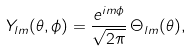Convert formula to latex. <formula><loc_0><loc_0><loc_500><loc_500>Y _ { l m } ( \theta , \phi ) = \frac { e ^ { i m \phi } } { \sqrt { 2 \pi } } \, \Theta _ { l m } ( \theta ) ,</formula> 